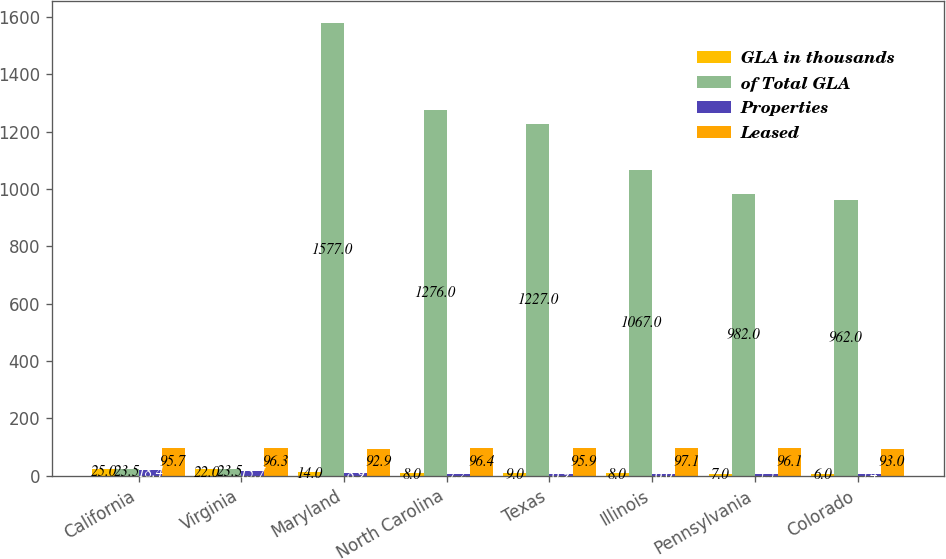Convert chart to OTSL. <chart><loc_0><loc_0><loc_500><loc_500><stacked_bar_chart><ecel><fcel>California<fcel>Virginia<fcel>Maryland<fcel>North Carolina<fcel>Texas<fcel>Illinois<fcel>Pennsylvania<fcel>Colorado<nl><fcel>GLA in thousands<fcel>25<fcel>22<fcel>14<fcel>8<fcel>9<fcel>8<fcel>7<fcel>6<nl><fcel>of Total GLA<fcel>23.5<fcel>23.5<fcel>1577<fcel>1276<fcel>1227<fcel>1067<fcel>982<fcel>962<nl><fcel>Properties<fcel>18.4<fcel>15.7<fcel>8.9<fcel>7.2<fcel>6.9<fcel>6<fcel>5.5<fcel>5.4<nl><fcel>Leased<fcel>95.7<fcel>96.3<fcel>92.9<fcel>96.4<fcel>95.9<fcel>97.1<fcel>96.1<fcel>93<nl></chart> 